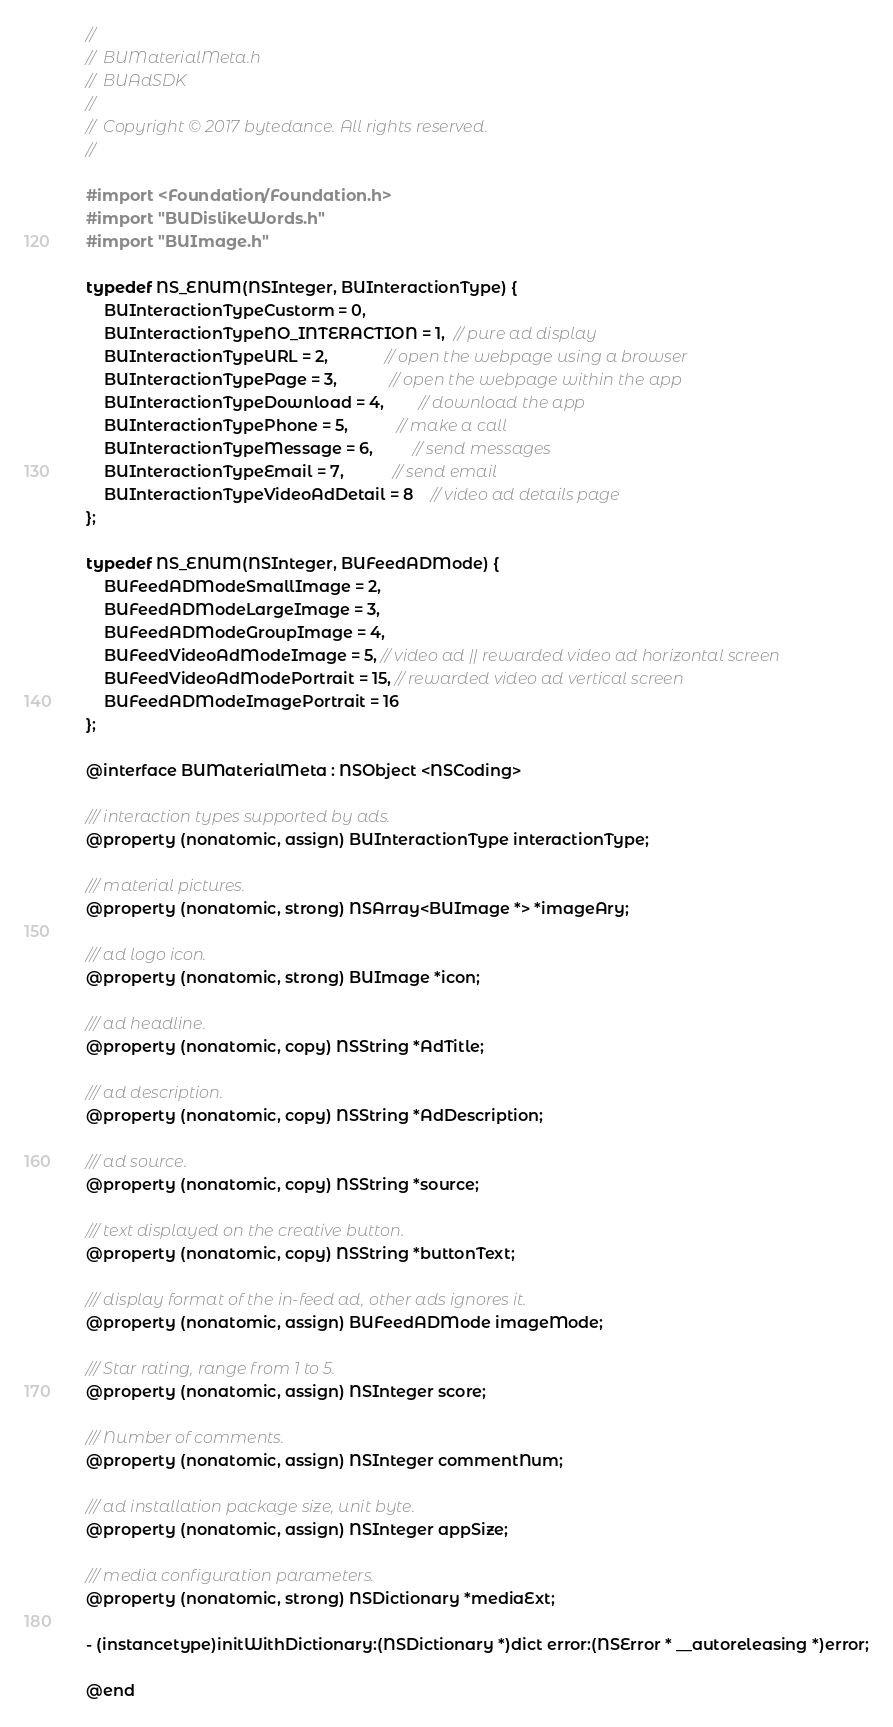Convert code to text. <code><loc_0><loc_0><loc_500><loc_500><_C_>//
//  BUMaterialMeta.h
//  BUAdSDK
//
//  Copyright © 2017 bytedance. All rights reserved.
//

#import <Foundation/Foundation.h>
#import "BUDislikeWords.h"
#import "BUImage.h"

typedef NS_ENUM(NSInteger, BUInteractionType) {
    BUInteractionTypeCustorm = 0,
    BUInteractionTypeNO_INTERACTION = 1,  // pure ad display
    BUInteractionTypeURL = 2,             // open the webpage using a browser
    BUInteractionTypePage = 3,            // open the webpage within the app
    BUInteractionTypeDownload = 4,        // download the app
    BUInteractionTypePhone = 5,           // make a call
    BUInteractionTypeMessage = 6,         // send messages
    BUInteractionTypeEmail = 7,           // send email
    BUInteractionTypeVideoAdDetail = 8    // video ad details page
};

typedef NS_ENUM(NSInteger, BUFeedADMode) {
    BUFeedADModeSmallImage = 2,
    BUFeedADModeLargeImage = 3,
    BUFeedADModeGroupImage = 4,
    BUFeedVideoAdModeImage = 5, // video ad || rewarded video ad horizontal screen
    BUFeedVideoAdModePortrait = 15, // rewarded video ad vertical screen
    BUFeedADModeImagePortrait = 16
};

@interface BUMaterialMeta : NSObject <NSCoding>

/// interaction types supported by ads.
@property (nonatomic, assign) BUInteractionType interactionType;

/// material pictures.
@property (nonatomic, strong) NSArray<BUImage *> *imageAry;

/// ad logo icon.
@property (nonatomic, strong) BUImage *icon;

/// ad headline.
@property (nonatomic, copy) NSString *AdTitle;

/// ad description.
@property (nonatomic, copy) NSString *AdDescription;

/// ad source.
@property (nonatomic, copy) NSString *source;

/// text displayed on the creative button.
@property (nonatomic, copy) NSString *buttonText;

/// display format of the in-feed ad, other ads ignores it.
@property (nonatomic, assign) BUFeedADMode imageMode;

/// Star rating, range from 1 to 5.
@property (nonatomic, assign) NSInteger score;

/// Number of comments.
@property (nonatomic, assign) NSInteger commentNum;

/// ad installation package size, unit byte.
@property (nonatomic, assign) NSInteger appSize;

/// media configuration parameters.
@property (nonatomic, strong) NSDictionary *mediaExt;

- (instancetype)initWithDictionary:(NSDictionary *)dict error:(NSError * __autoreleasing *)error;

@end

</code> 